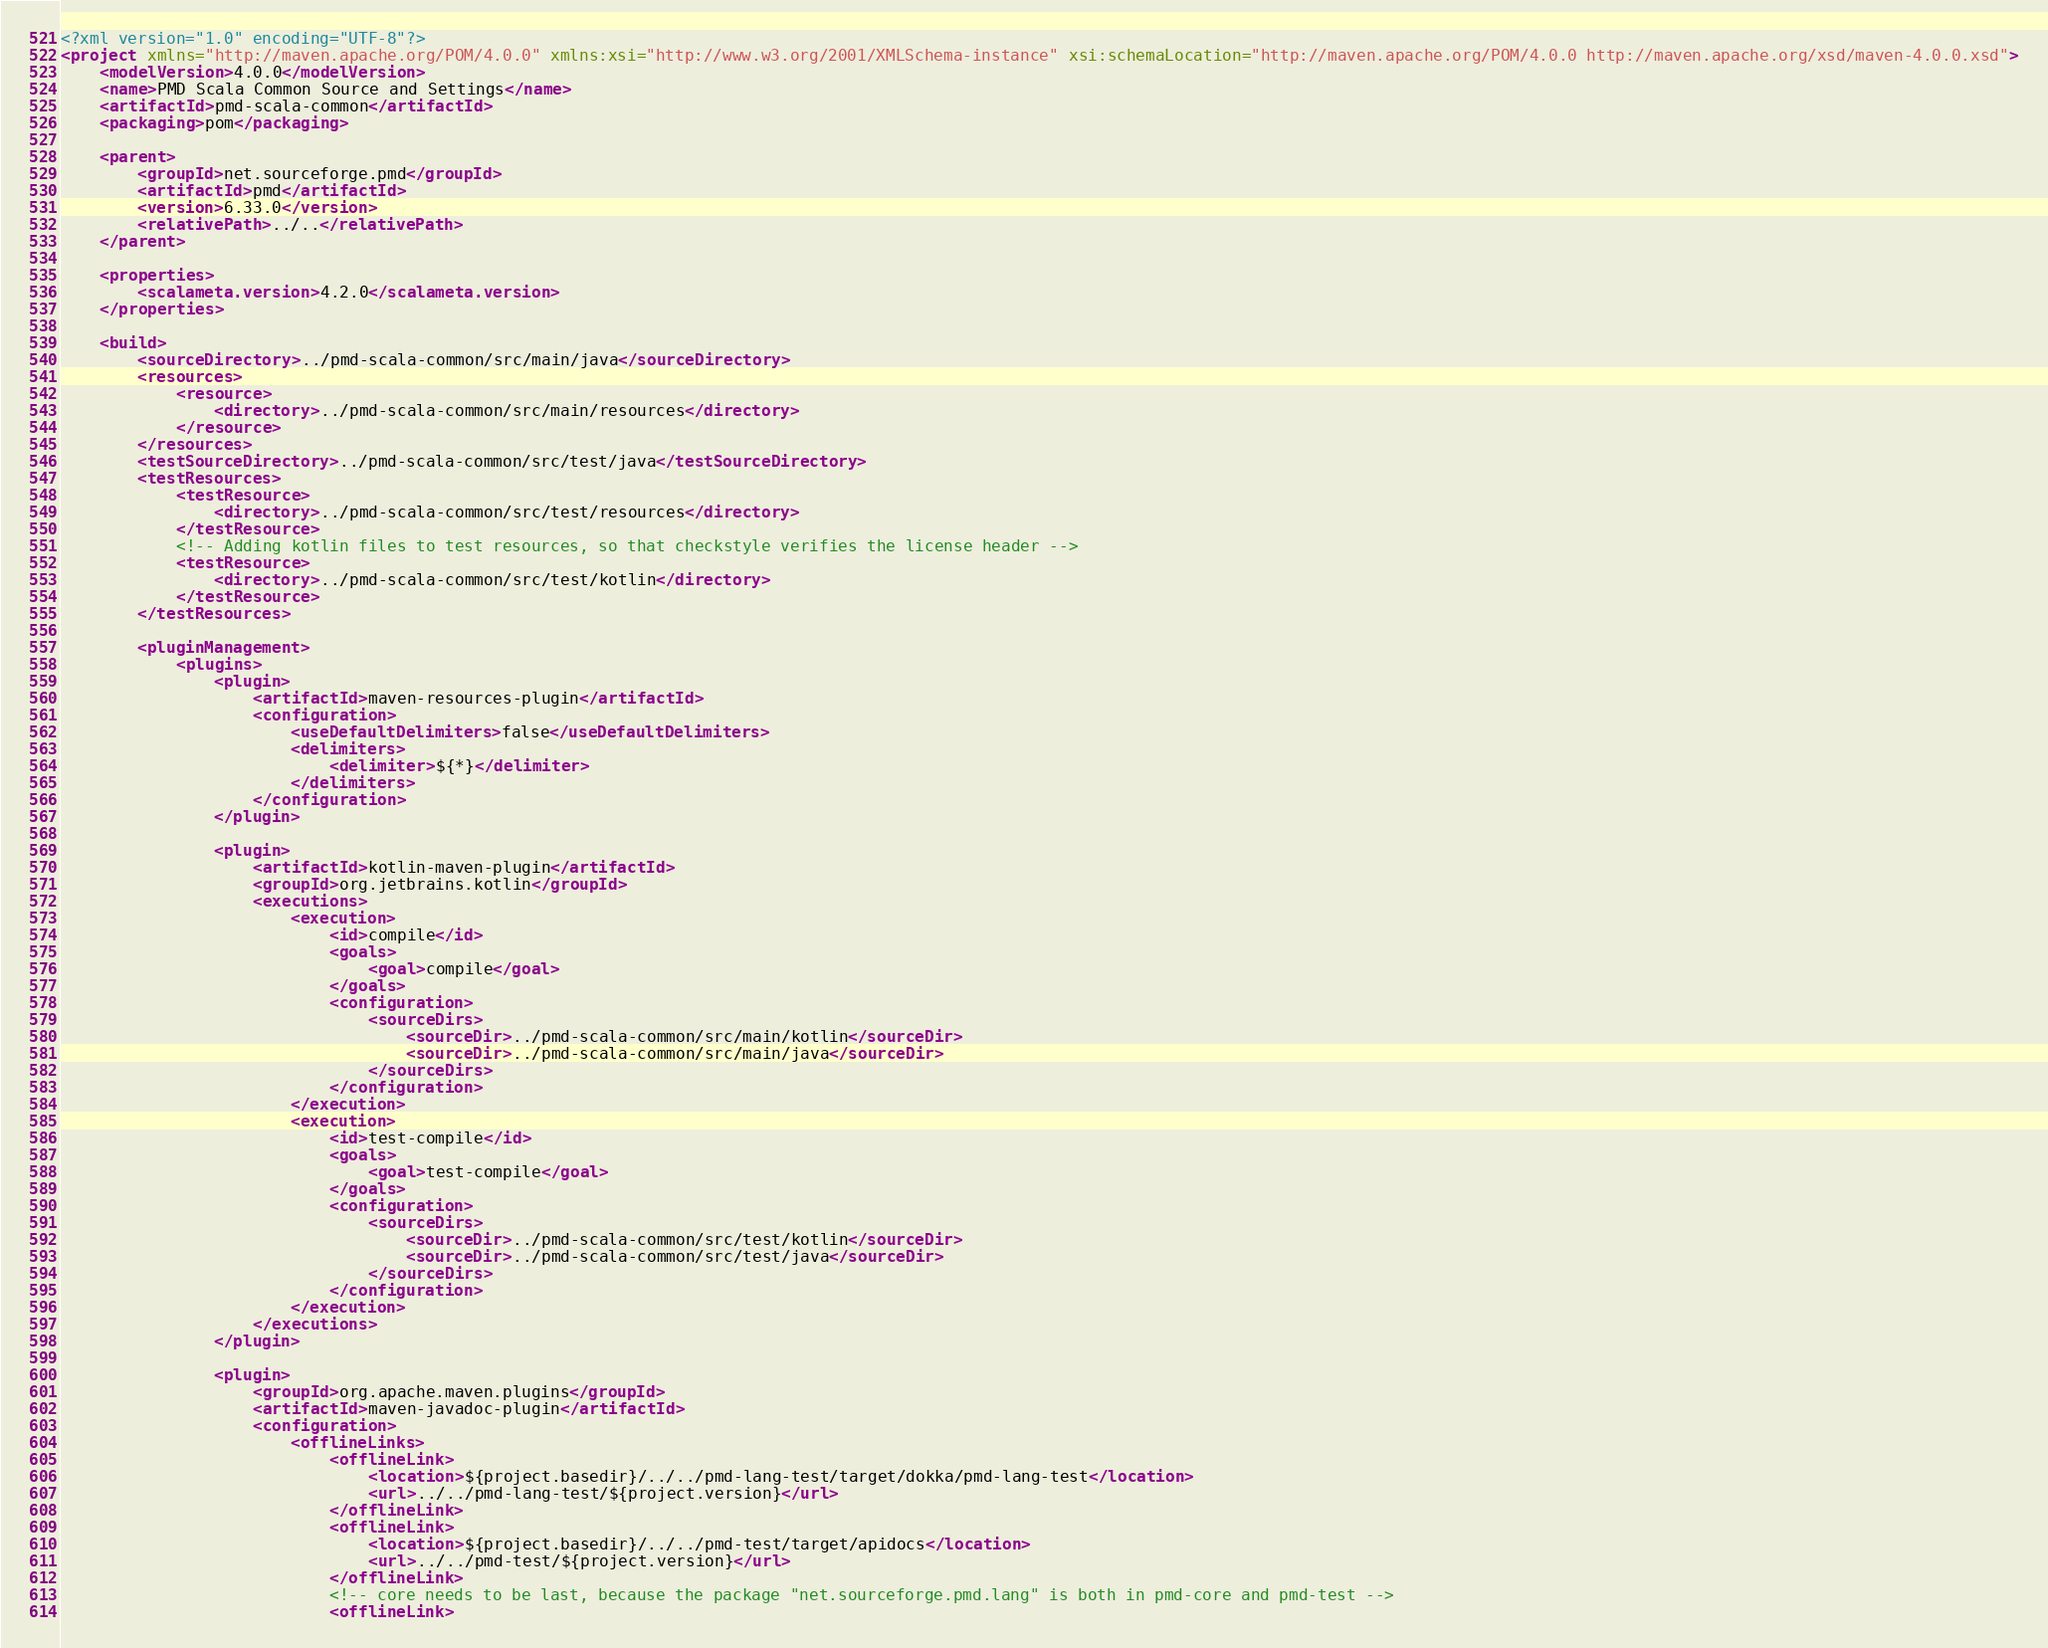<code> <loc_0><loc_0><loc_500><loc_500><_XML_><?xml version="1.0" encoding="UTF-8"?>
<project xmlns="http://maven.apache.org/POM/4.0.0" xmlns:xsi="http://www.w3.org/2001/XMLSchema-instance" xsi:schemaLocation="http://maven.apache.org/POM/4.0.0 http://maven.apache.org/xsd/maven-4.0.0.xsd">
    <modelVersion>4.0.0</modelVersion>
    <name>PMD Scala Common Source and Settings</name>
    <artifactId>pmd-scala-common</artifactId>
    <packaging>pom</packaging>

    <parent>
        <groupId>net.sourceforge.pmd</groupId>
        <artifactId>pmd</artifactId>
        <version>6.33.0</version>
        <relativePath>../..</relativePath>
    </parent>

    <properties>
        <scalameta.version>4.2.0</scalameta.version>
    </properties>

    <build>
        <sourceDirectory>../pmd-scala-common/src/main/java</sourceDirectory>
        <resources>
            <resource>
                <directory>../pmd-scala-common/src/main/resources</directory>
            </resource>
        </resources>
        <testSourceDirectory>../pmd-scala-common/src/test/java</testSourceDirectory>
        <testResources>
            <testResource>
                <directory>../pmd-scala-common/src/test/resources</directory>
            </testResource>
            <!-- Adding kotlin files to test resources, so that checkstyle verifies the license header -->
            <testResource>
                <directory>../pmd-scala-common/src/test/kotlin</directory>
            </testResource>
        </testResources>

        <pluginManagement>
            <plugins>
                <plugin>
                    <artifactId>maven-resources-plugin</artifactId>
                    <configuration>
                        <useDefaultDelimiters>false</useDefaultDelimiters>
                        <delimiters>
                            <delimiter>${*}</delimiter>
                        </delimiters>
                    </configuration>
                </plugin>

                <plugin>
                    <artifactId>kotlin-maven-plugin</artifactId>
                    <groupId>org.jetbrains.kotlin</groupId>
                    <executions>
                        <execution>
                            <id>compile</id>
                            <goals>
                                <goal>compile</goal>
                            </goals>
                            <configuration>
                                <sourceDirs>
                                    <sourceDir>../pmd-scala-common/src/main/kotlin</sourceDir>
                                    <sourceDir>../pmd-scala-common/src/main/java</sourceDir>
                                </sourceDirs>
                            </configuration>
                        </execution>
                        <execution>
                            <id>test-compile</id>
                            <goals>
                                <goal>test-compile</goal>
                            </goals>
                            <configuration>
                                <sourceDirs>
                                    <sourceDir>../pmd-scala-common/src/test/kotlin</sourceDir>
                                    <sourceDir>../pmd-scala-common/src/test/java</sourceDir>
                                </sourceDirs>
                            </configuration>
                        </execution>
                    </executions>
                </plugin>

                <plugin>
                    <groupId>org.apache.maven.plugins</groupId>
                    <artifactId>maven-javadoc-plugin</artifactId>
                    <configuration>
                        <offlineLinks>
                            <offlineLink>
                                <location>${project.basedir}/../../pmd-lang-test/target/dokka/pmd-lang-test</location>
                                <url>../../pmd-lang-test/${project.version}</url>
                            </offlineLink>
                            <offlineLink>
                                <location>${project.basedir}/../../pmd-test/target/apidocs</location>
                                <url>../../pmd-test/${project.version}</url>
                            </offlineLink>
                            <!-- core needs to be last, because the package "net.sourceforge.pmd.lang" is both in pmd-core and pmd-test -->
                            <offlineLink></code> 